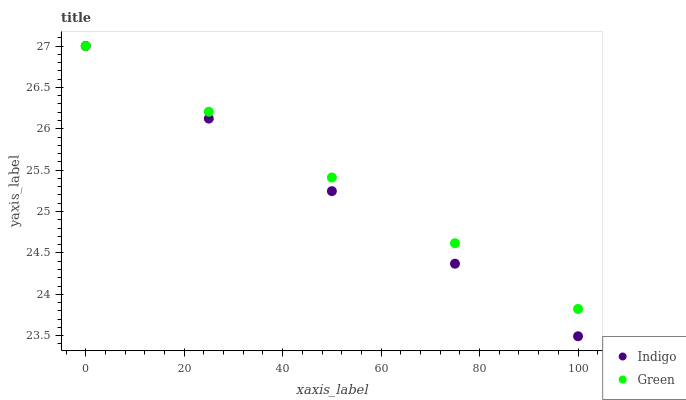Does Indigo have the minimum area under the curve?
Answer yes or no. Yes. Does Green have the maximum area under the curve?
Answer yes or no. Yes. Does Indigo have the maximum area under the curve?
Answer yes or no. No. Is Indigo the smoothest?
Answer yes or no. Yes. Is Green the roughest?
Answer yes or no. Yes. Is Indigo the roughest?
Answer yes or no. No. Does Indigo have the lowest value?
Answer yes or no. Yes. Does Indigo have the highest value?
Answer yes or no. Yes. Does Green intersect Indigo?
Answer yes or no. Yes. Is Green less than Indigo?
Answer yes or no. No. Is Green greater than Indigo?
Answer yes or no. No. 